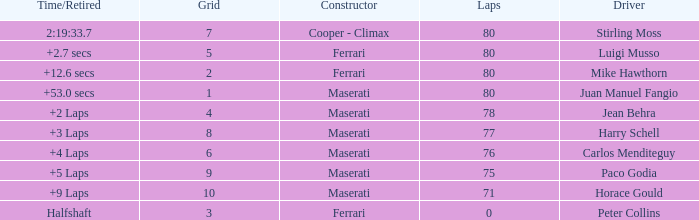Who was driving the Maserati with a Grid smaller than 6, and a Time/Retired of +2 laps? Jean Behra. 